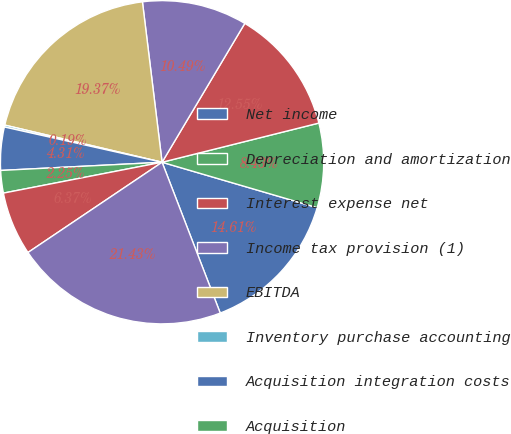Convert chart to OTSL. <chart><loc_0><loc_0><loc_500><loc_500><pie_chart><fcel>Net income<fcel>Depreciation and amortization<fcel>Interest expense net<fcel>Income tax provision (1)<fcel>EBITDA<fcel>Inventory purchase accounting<fcel>Acquisition integration costs<fcel>Acquisition<fcel>Non-cash stock and deferred<fcel>EBITDA As Defined<nl><fcel>14.61%<fcel>8.43%<fcel>12.55%<fcel>10.49%<fcel>19.37%<fcel>0.19%<fcel>4.31%<fcel>2.25%<fcel>6.37%<fcel>21.43%<nl></chart> 